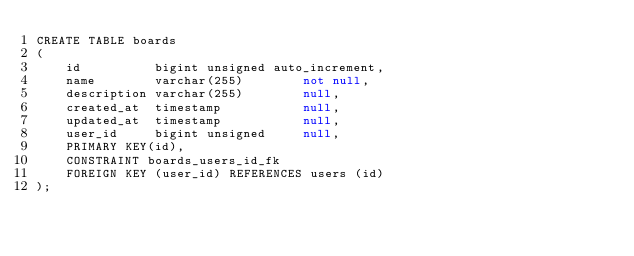Convert code to text. <code><loc_0><loc_0><loc_500><loc_500><_SQL_>CREATE TABLE boards
(
    id          bigint unsigned auto_increment,
    name        varchar(255)        not null,
    description varchar(255)        null,
    created_at  timestamp           null,
    updated_at  timestamp           null,
    user_id     bigint unsigned     null,
    PRIMARY KEY(id),
    CONSTRAINT boards_users_id_fk
    FOREIGN KEY (user_id) REFERENCES users (id)
);
</code> 